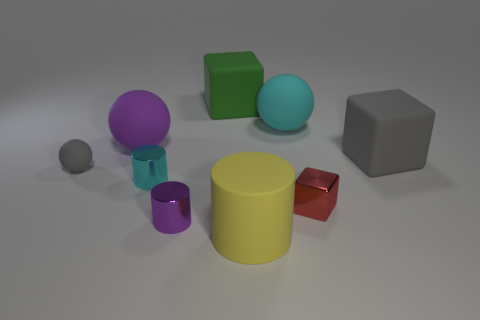Are there more spherical objects or cubic objects in the scene? There are two spherical objects and two cubic objects, so the number is equal for both shapes in this scene. 